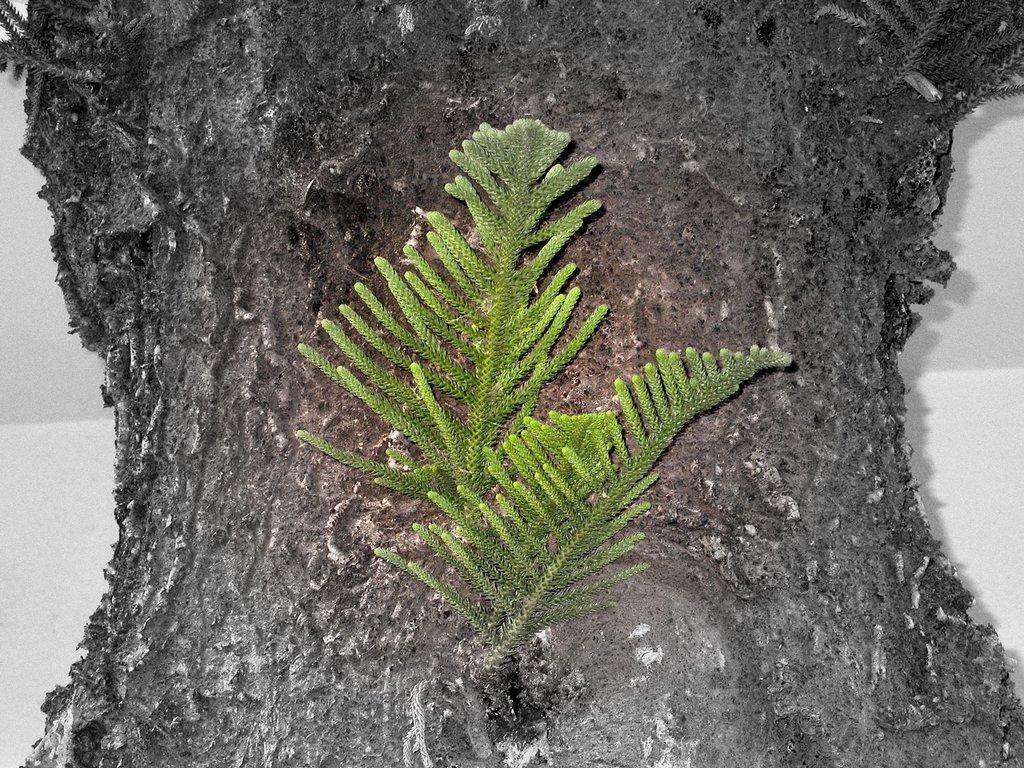Could you give a brief overview of what you see in this image? In the center of the image, we can see leaves and in the background, there is a tree trunk and a wall. 